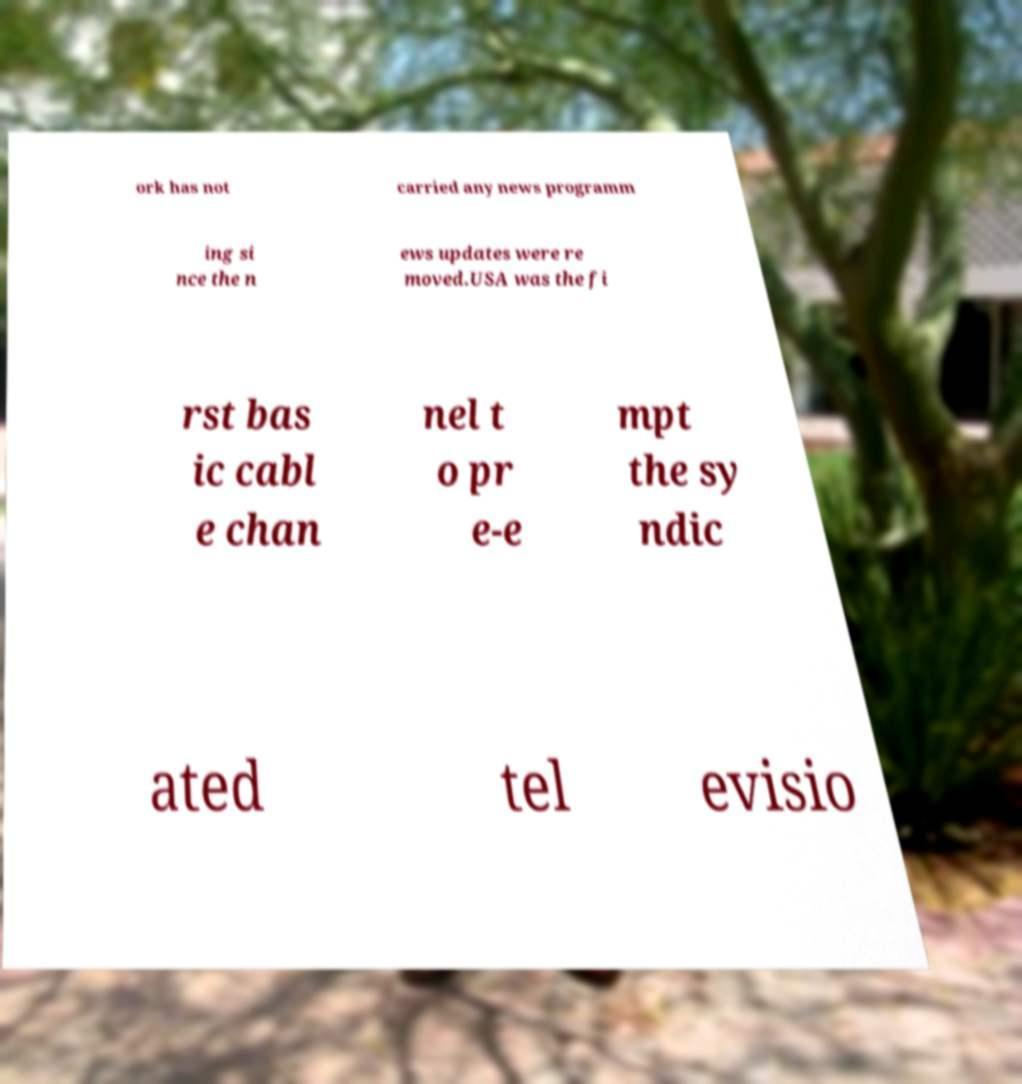Can you read and provide the text displayed in the image?This photo seems to have some interesting text. Can you extract and type it out for me? ork has not carried any news programm ing si nce the n ews updates were re moved.USA was the fi rst bas ic cabl e chan nel t o pr e-e mpt the sy ndic ated tel evisio 